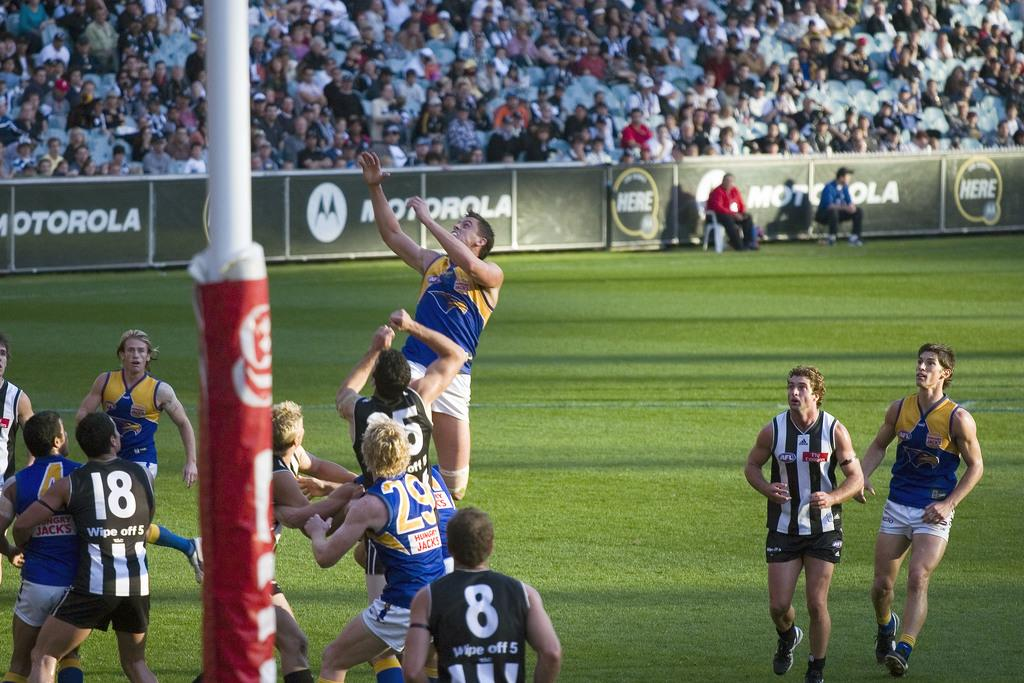Provide a one-sentence caption for the provided image. A rugby match is being played in a field with the motorola advertisement in the background. 